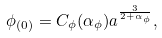<formula> <loc_0><loc_0><loc_500><loc_500>\phi _ { ( 0 ) } = C _ { \phi } ( \alpha _ { \phi } ) { a } ^ { \frac { 3 } { 2 + \alpha _ { \phi } } } ,</formula> 